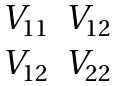<formula> <loc_0><loc_0><loc_500><loc_500>\begin{matrix} V _ { 1 1 } & V _ { 1 2 } \\ V _ { 1 2 } & V _ { 2 2 } \end{matrix}</formula> 